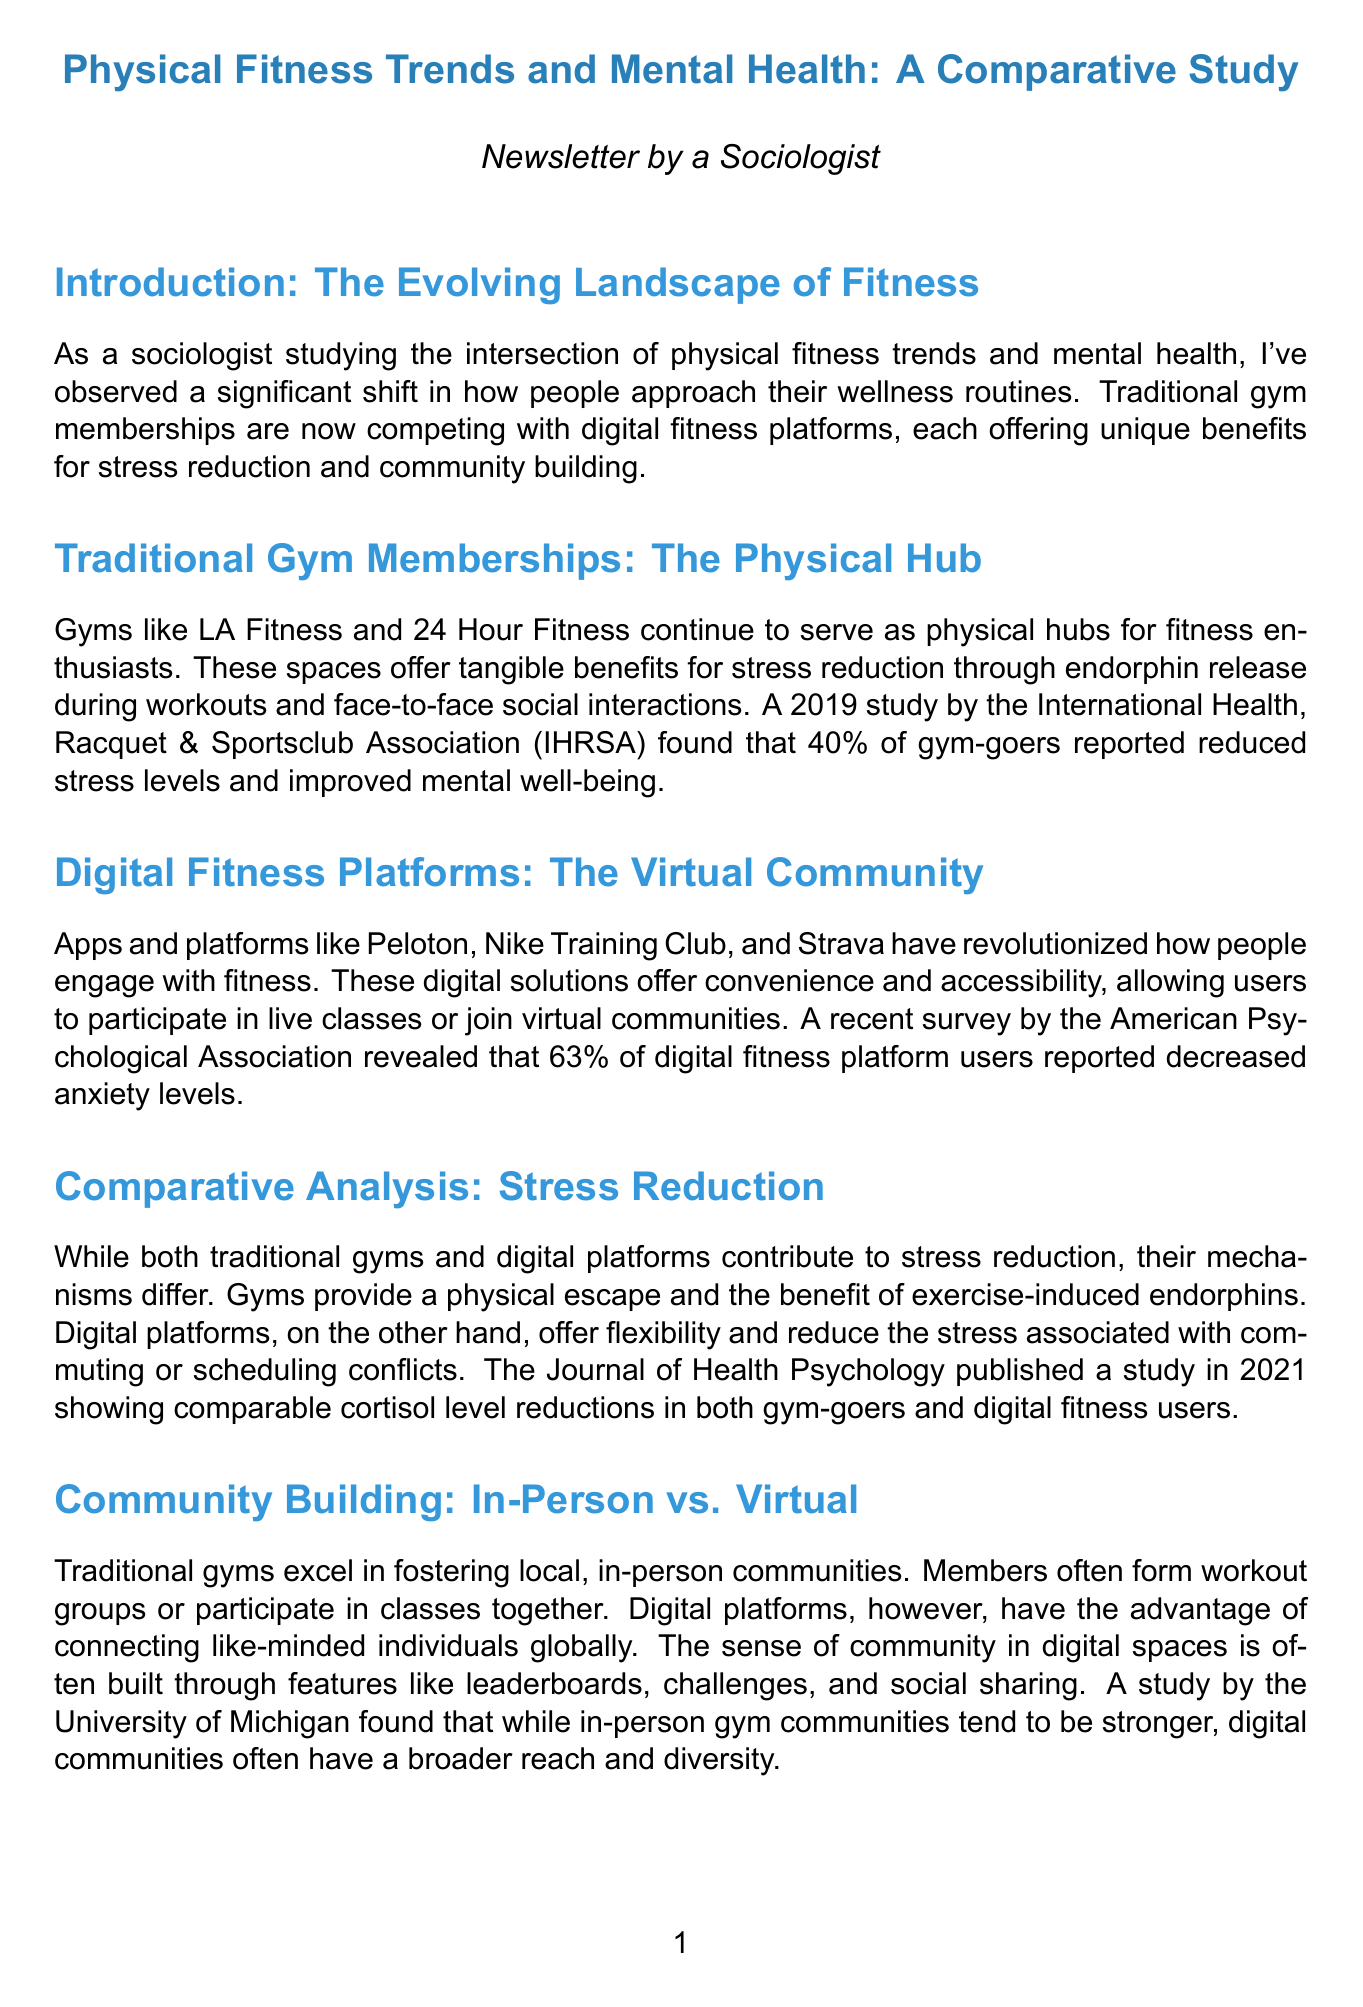What percentage of gym-goers reported reduced stress levels? The document states that 40% of gym-goers reported reduced stress levels, based on a study by IHRSA.
Answer: 40% Which digital fitness platform reported a 35% increase in daily active users during the COVID-19 pandemic? MyFitnessPal is specifically mentioned as seeing this increase attributed to its supportive online community.
Answer: MyFitnessPal What is the term used by Planet Fitness to describe its community environment? The document refers to Planet Fitness's environment as a "Judgement Free Zone."
Answer: Judgement Free Zone What did the American Psychological Association survey find regarding digital fitness platform users? The survey found that 63% of digital fitness platform users reported decreased anxiety levels.
Answer: 63% Which study published in 2021 compared cortisol level reductions in gym-goers and digital fitness users? The Journal of Health Psychology published this study comparing the effects on cortisol levels.
Answer: Journal of Health Psychology What are the two main types of communities discussed in the newsletter? The document discusses "in-person" communities typical of traditional gyms and "virtual" communities of digital platforms.
Answer: In-person and virtual What future model does the conclusion suggest for fitness and mental health? The conclusion suggests a hybrid model that combines both traditional gyms and digital platforms as a comprehensive approach.
Answer: Hybrid model Who is the author of 'Move The Body, Heal The Mind'? The document attributes this work to Dr. Jennifer Heisz.
Answer: Dr. Jennifer Heisz 